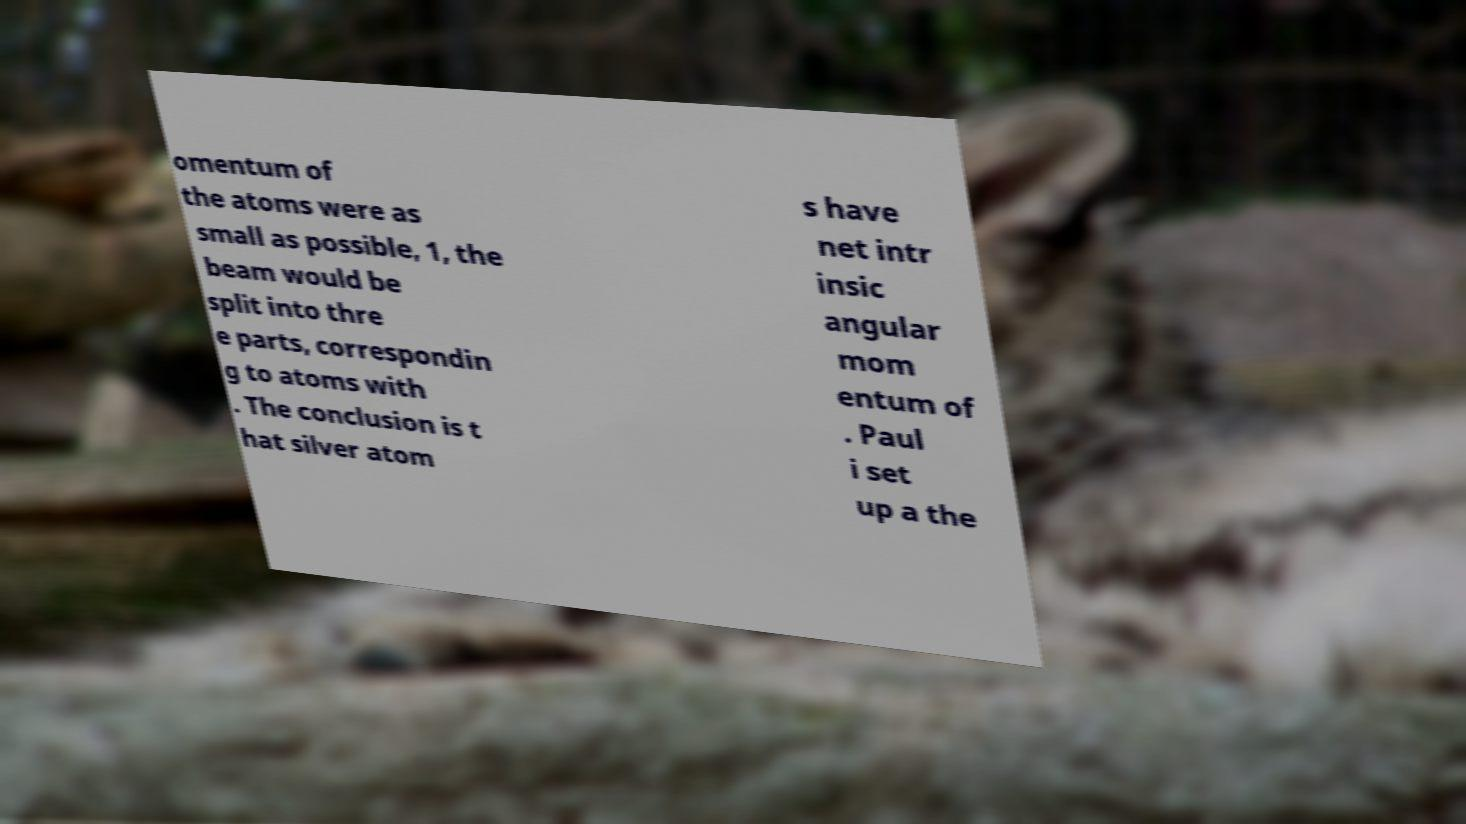There's text embedded in this image that I need extracted. Can you transcribe it verbatim? omentum of the atoms were as small as possible, 1, the beam would be split into thre e parts, correspondin g to atoms with . The conclusion is t hat silver atom s have net intr insic angular mom entum of . Paul i set up a the 